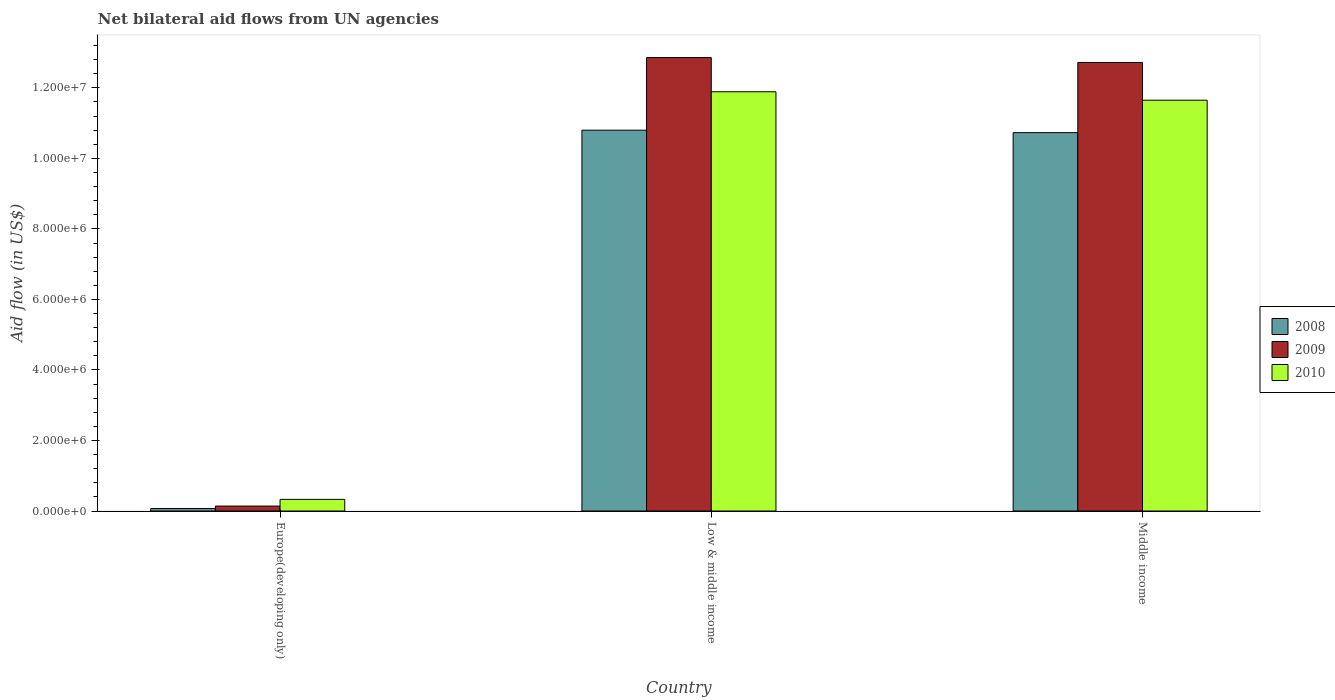How many bars are there on the 3rd tick from the right?
Your response must be concise. 3. What is the net bilateral aid flow in 2010 in Low & middle income?
Offer a very short reply. 1.19e+07. Across all countries, what is the maximum net bilateral aid flow in 2010?
Provide a short and direct response. 1.19e+07. In which country was the net bilateral aid flow in 2010 maximum?
Provide a succinct answer. Low & middle income. In which country was the net bilateral aid flow in 2010 minimum?
Provide a short and direct response. Europe(developing only). What is the total net bilateral aid flow in 2008 in the graph?
Offer a very short reply. 2.16e+07. What is the difference between the net bilateral aid flow in 2009 in Low & middle income and that in Middle income?
Ensure brevity in your answer.  1.40e+05. What is the difference between the net bilateral aid flow in 2009 in Low & middle income and the net bilateral aid flow in 2008 in Middle income?
Provide a succinct answer. 2.13e+06. What is the average net bilateral aid flow in 2009 per country?
Your answer should be very brief. 8.57e+06. What is the difference between the net bilateral aid flow of/in 2010 and net bilateral aid flow of/in 2009 in Europe(developing only)?
Offer a very short reply. 1.90e+05. What is the ratio of the net bilateral aid flow in 2010 in Low & middle income to that in Middle income?
Ensure brevity in your answer.  1.02. What is the difference between the highest and the second highest net bilateral aid flow in 2010?
Provide a succinct answer. 1.16e+07. What is the difference between the highest and the lowest net bilateral aid flow in 2009?
Your answer should be compact. 1.27e+07. Is the sum of the net bilateral aid flow in 2009 in Europe(developing only) and Middle income greater than the maximum net bilateral aid flow in 2008 across all countries?
Offer a very short reply. Yes. What does the 1st bar from the left in Low & middle income represents?
Your answer should be compact. 2008. Is it the case that in every country, the sum of the net bilateral aid flow in 2008 and net bilateral aid flow in 2009 is greater than the net bilateral aid flow in 2010?
Your answer should be compact. No. How many bars are there?
Provide a succinct answer. 9. How many countries are there in the graph?
Offer a terse response. 3. Are the values on the major ticks of Y-axis written in scientific E-notation?
Ensure brevity in your answer.  Yes. Does the graph contain grids?
Make the answer very short. No. How are the legend labels stacked?
Provide a succinct answer. Vertical. What is the title of the graph?
Keep it short and to the point. Net bilateral aid flows from UN agencies. What is the label or title of the Y-axis?
Provide a succinct answer. Aid flow (in US$). What is the Aid flow (in US$) in 2008 in Europe(developing only)?
Ensure brevity in your answer.  7.00e+04. What is the Aid flow (in US$) in 2009 in Europe(developing only)?
Offer a very short reply. 1.40e+05. What is the Aid flow (in US$) in 2010 in Europe(developing only)?
Provide a succinct answer. 3.30e+05. What is the Aid flow (in US$) of 2008 in Low & middle income?
Offer a terse response. 1.08e+07. What is the Aid flow (in US$) in 2009 in Low & middle income?
Offer a terse response. 1.29e+07. What is the Aid flow (in US$) in 2010 in Low & middle income?
Keep it short and to the point. 1.19e+07. What is the Aid flow (in US$) in 2008 in Middle income?
Your response must be concise. 1.07e+07. What is the Aid flow (in US$) of 2009 in Middle income?
Offer a terse response. 1.27e+07. What is the Aid flow (in US$) in 2010 in Middle income?
Make the answer very short. 1.16e+07. Across all countries, what is the maximum Aid flow (in US$) in 2008?
Your answer should be compact. 1.08e+07. Across all countries, what is the maximum Aid flow (in US$) of 2009?
Offer a terse response. 1.29e+07. Across all countries, what is the maximum Aid flow (in US$) in 2010?
Offer a terse response. 1.19e+07. Across all countries, what is the minimum Aid flow (in US$) in 2009?
Give a very brief answer. 1.40e+05. Across all countries, what is the minimum Aid flow (in US$) in 2010?
Provide a succinct answer. 3.30e+05. What is the total Aid flow (in US$) of 2008 in the graph?
Offer a very short reply. 2.16e+07. What is the total Aid flow (in US$) in 2009 in the graph?
Give a very brief answer. 2.57e+07. What is the total Aid flow (in US$) in 2010 in the graph?
Your answer should be compact. 2.39e+07. What is the difference between the Aid flow (in US$) in 2008 in Europe(developing only) and that in Low & middle income?
Offer a terse response. -1.07e+07. What is the difference between the Aid flow (in US$) in 2009 in Europe(developing only) and that in Low & middle income?
Keep it short and to the point. -1.27e+07. What is the difference between the Aid flow (in US$) of 2010 in Europe(developing only) and that in Low & middle income?
Make the answer very short. -1.16e+07. What is the difference between the Aid flow (in US$) in 2008 in Europe(developing only) and that in Middle income?
Keep it short and to the point. -1.07e+07. What is the difference between the Aid flow (in US$) of 2009 in Europe(developing only) and that in Middle income?
Keep it short and to the point. -1.26e+07. What is the difference between the Aid flow (in US$) in 2010 in Europe(developing only) and that in Middle income?
Offer a terse response. -1.13e+07. What is the difference between the Aid flow (in US$) in 2009 in Low & middle income and that in Middle income?
Make the answer very short. 1.40e+05. What is the difference between the Aid flow (in US$) of 2010 in Low & middle income and that in Middle income?
Your answer should be very brief. 2.40e+05. What is the difference between the Aid flow (in US$) of 2008 in Europe(developing only) and the Aid flow (in US$) of 2009 in Low & middle income?
Ensure brevity in your answer.  -1.28e+07. What is the difference between the Aid flow (in US$) in 2008 in Europe(developing only) and the Aid flow (in US$) in 2010 in Low & middle income?
Keep it short and to the point. -1.18e+07. What is the difference between the Aid flow (in US$) of 2009 in Europe(developing only) and the Aid flow (in US$) of 2010 in Low & middle income?
Keep it short and to the point. -1.18e+07. What is the difference between the Aid flow (in US$) in 2008 in Europe(developing only) and the Aid flow (in US$) in 2009 in Middle income?
Your answer should be very brief. -1.26e+07. What is the difference between the Aid flow (in US$) in 2008 in Europe(developing only) and the Aid flow (in US$) in 2010 in Middle income?
Your answer should be very brief. -1.16e+07. What is the difference between the Aid flow (in US$) in 2009 in Europe(developing only) and the Aid flow (in US$) in 2010 in Middle income?
Your answer should be compact. -1.15e+07. What is the difference between the Aid flow (in US$) in 2008 in Low & middle income and the Aid flow (in US$) in 2009 in Middle income?
Your answer should be very brief. -1.92e+06. What is the difference between the Aid flow (in US$) in 2008 in Low & middle income and the Aid flow (in US$) in 2010 in Middle income?
Keep it short and to the point. -8.50e+05. What is the difference between the Aid flow (in US$) of 2009 in Low & middle income and the Aid flow (in US$) of 2010 in Middle income?
Your answer should be compact. 1.21e+06. What is the average Aid flow (in US$) of 2008 per country?
Keep it short and to the point. 7.20e+06. What is the average Aid flow (in US$) in 2009 per country?
Your answer should be very brief. 8.57e+06. What is the average Aid flow (in US$) of 2010 per country?
Your answer should be very brief. 7.96e+06. What is the difference between the Aid flow (in US$) of 2008 and Aid flow (in US$) of 2009 in Low & middle income?
Your response must be concise. -2.06e+06. What is the difference between the Aid flow (in US$) of 2008 and Aid flow (in US$) of 2010 in Low & middle income?
Provide a succinct answer. -1.09e+06. What is the difference between the Aid flow (in US$) in 2009 and Aid flow (in US$) in 2010 in Low & middle income?
Keep it short and to the point. 9.70e+05. What is the difference between the Aid flow (in US$) in 2008 and Aid flow (in US$) in 2009 in Middle income?
Provide a succinct answer. -1.99e+06. What is the difference between the Aid flow (in US$) of 2008 and Aid flow (in US$) of 2010 in Middle income?
Give a very brief answer. -9.20e+05. What is the difference between the Aid flow (in US$) in 2009 and Aid flow (in US$) in 2010 in Middle income?
Give a very brief answer. 1.07e+06. What is the ratio of the Aid flow (in US$) of 2008 in Europe(developing only) to that in Low & middle income?
Your response must be concise. 0.01. What is the ratio of the Aid flow (in US$) in 2009 in Europe(developing only) to that in Low & middle income?
Your answer should be very brief. 0.01. What is the ratio of the Aid flow (in US$) in 2010 in Europe(developing only) to that in Low & middle income?
Provide a short and direct response. 0.03. What is the ratio of the Aid flow (in US$) of 2008 in Europe(developing only) to that in Middle income?
Ensure brevity in your answer.  0.01. What is the ratio of the Aid flow (in US$) of 2009 in Europe(developing only) to that in Middle income?
Provide a succinct answer. 0.01. What is the ratio of the Aid flow (in US$) in 2010 in Europe(developing only) to that in Middle income?
Ensure brevity in your answer.  0.03. What is the ratio of the Aid flow (in US$) in 2008 in Low & middle income to that in Middle income?
Offer a terse response. 1.01. What is the ratio of the Aid flow (in US$) in 2009 in Low & middle income to that in Middle income?
Provide a succinct answer. 1.01. What is the ratio of the Aid flow (in US$) in 2010 in Low & middle income to that in Middle income?
Provide a succinct answer. 1.02. What is the difference between the highest and the second highest Aid flow (in US$) of 2010?
Give a very brief answer. 2.40e+05. What is the difference between the highest and the lowest Aid flow (in US$) of 2008?
Your answer should be compact. 1.07e+07. What is the difference between the highest and the lowest Aid flow (in US$) of 2009?
Offer a very short reply. 1.27e+07. What is the difference between the highest and the lowest Aid flow (in US$) in 2010?
Provide a succinct answer. 1.16e+07. 